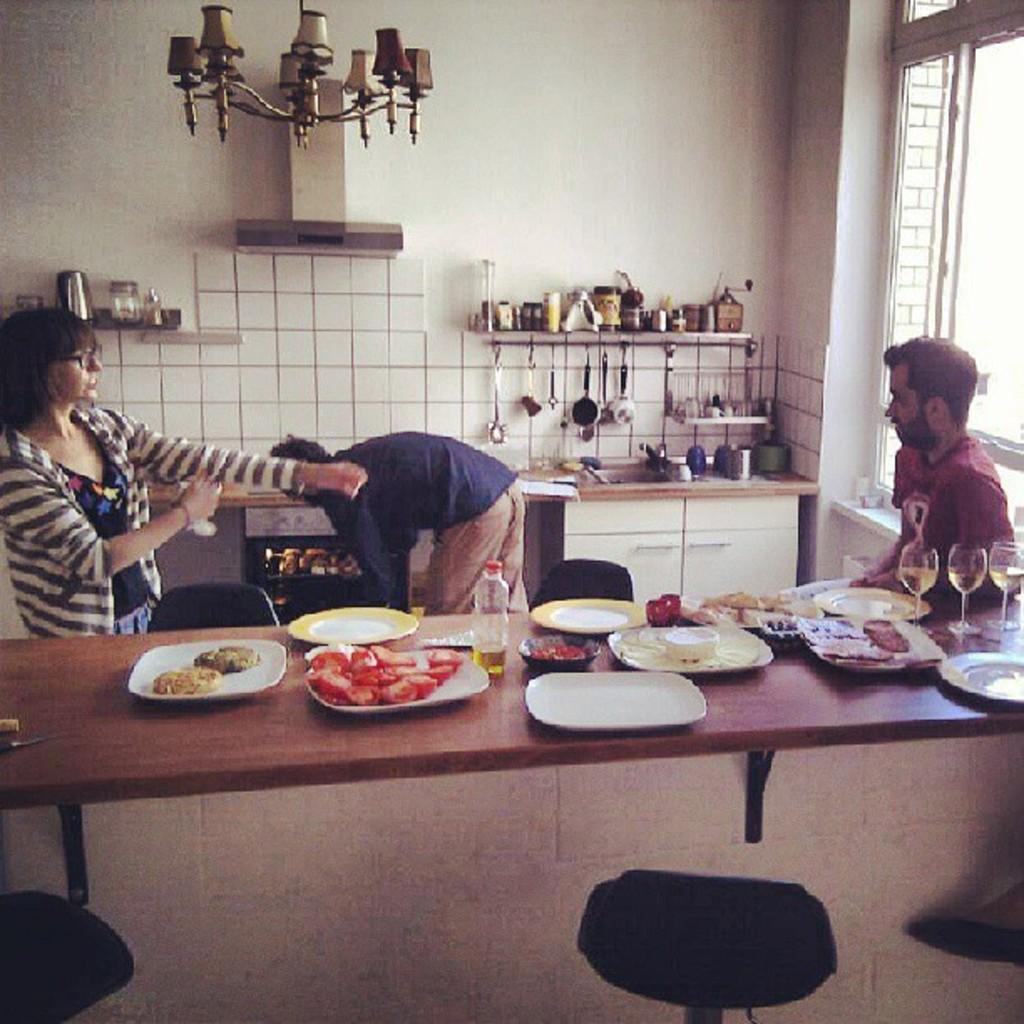How many people are in the room in the image? There are three people in the room. What can be found on the table in the image? There is food and glasses on the table. Where can spoons be found in the room? There is a spoons stand in the room. What type of lighting fixture is present in the room? There is a chandelier in the room. What type of comb is used to adjust the acoustics in the room? There is no comb present in the image, and the acoustics of the room are not mentioned. 